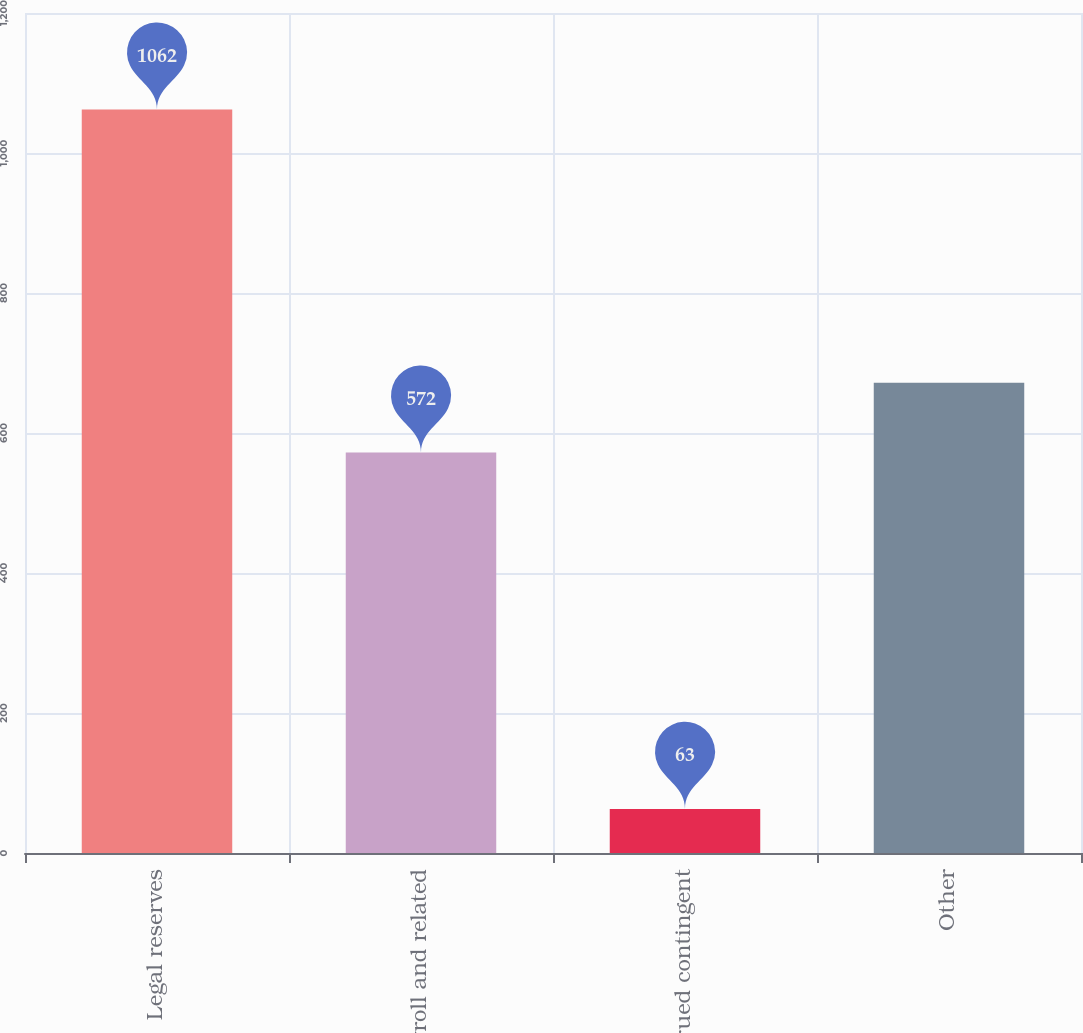<chart> <loc_0><loc_0><loc_500><loc_500><bar_chart><fcel>Legal reserves<fcel>Payroll and related<fcel>Accrued contingent<fcel>Other<nl><fcel>1062<fcel>572<fcel>63<fcel>671.9<nl></chart> 